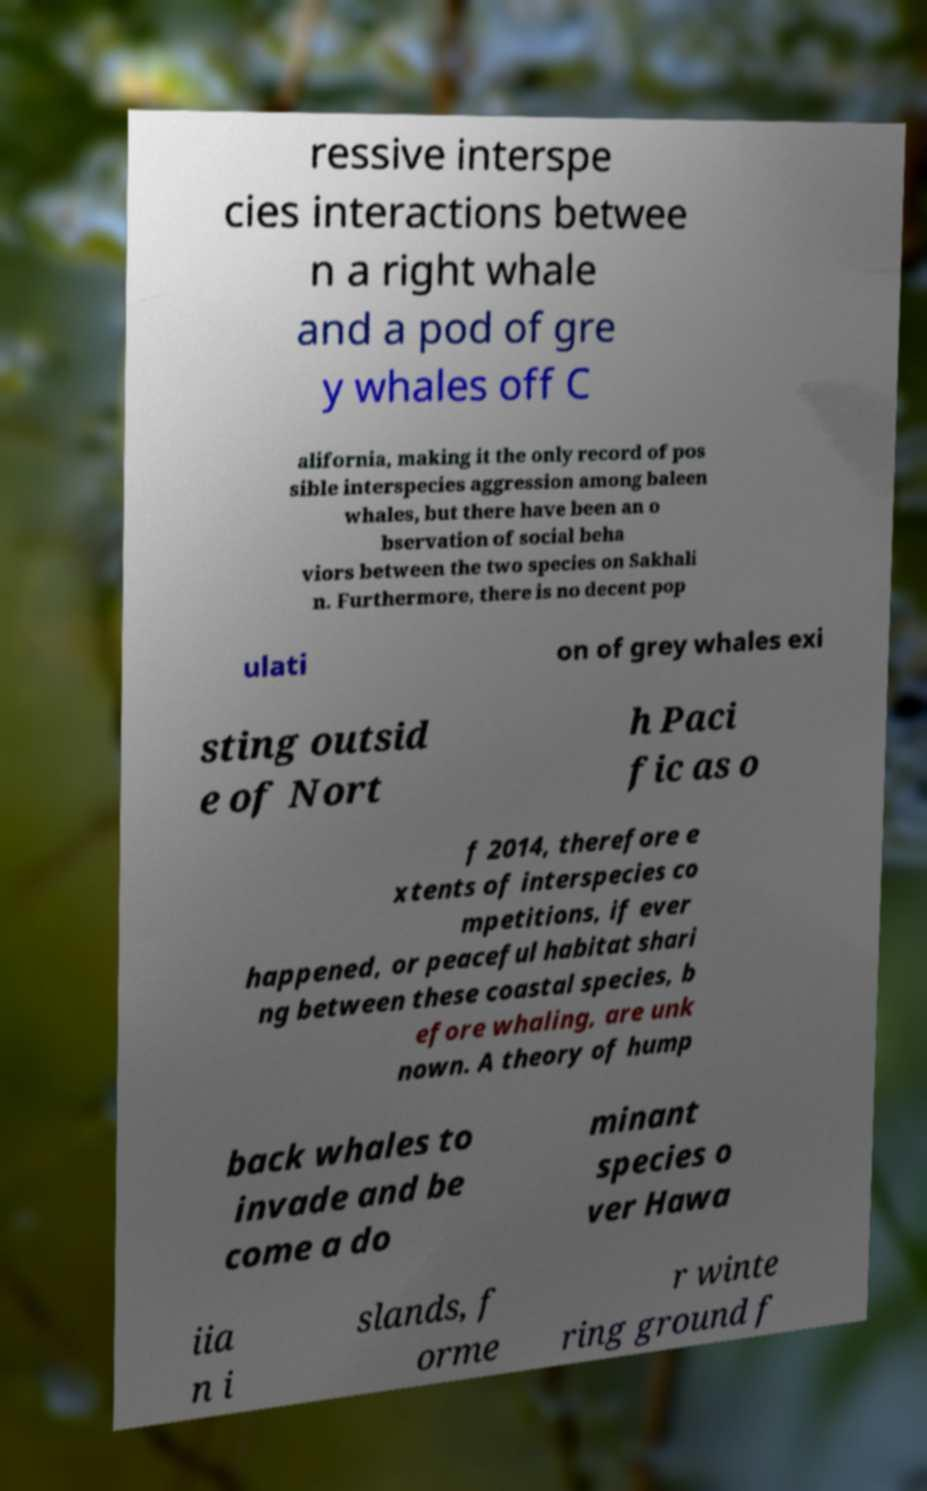Could you extract and type out the text from this image? ressive interspe cies interactions betwee n a right whale and a pod of gre y whales off C alifornia, making it the only record of pos sible interspecies aggression among baleen whales, but there have been an o bservation of social beha viors between the two species on Sakhali n. Furthermore, there is no decent pop ulati on of grey whales exi sting outsid e of Nort h Paci fic as o f 2014, therefore e xtents of interspecies co mpetitions, if ever happened, or peaceful habitat shari ng between these coastal species, b efore whaling, are unk nown. A theory of hump back whales to invade and be come a do minant species o ver Hawa iia n i slands, f orme r winte ring ground f 